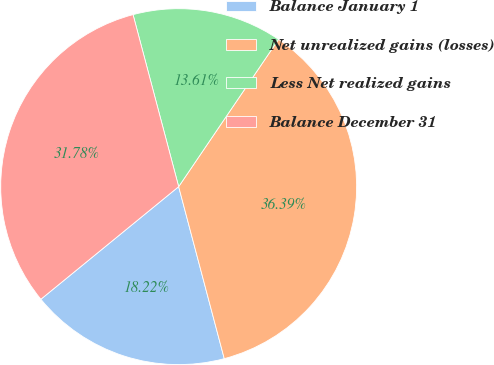Convert chart. <chart><loc_0><loc_0><loc_500><loc_500><pie_chart><fcel>Balance January 1<fcel>Net unrealized gains (losses)<fcel>Less Net realized gains<fcel>Balance December 31<nl><fcel>18.22%<fcel>36.39%<fcel>13.61%<fcel>31.78%<nl></chart> 